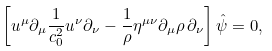<formula> <loc_0><loc_0><loc_500><loc_500>\left [ u ^ { \mu } \partial _ { \mu } \frac { 1 } { c _ { 0 } ^ { 2 } } u ^ { \nu } \partial _ { \nu } - \frac { 1 } { \rho } \eta ^ { \mu \nu } \partial _ { \mu } \rho \, \partial _ { \nu } \right ] \hat { \psi } = 0 ,</formula> 